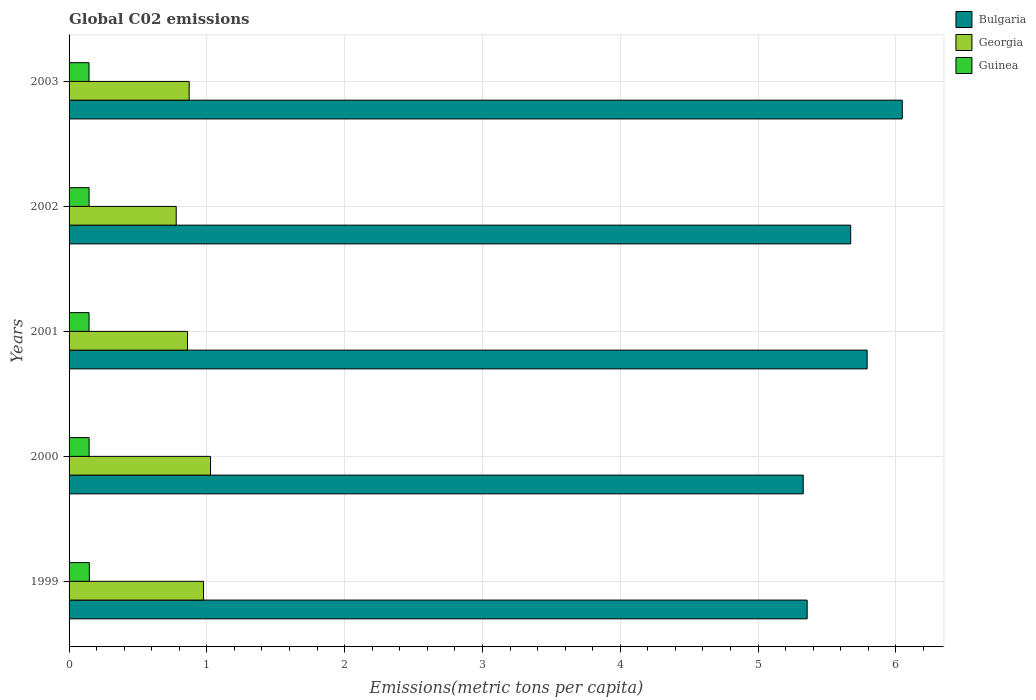Are the number of bars per tick equal to the number of legend labels?
Offer a terse response. Yes. Are the number of bars on each tick of the Y-axis equal?
Make the answer very short. Yes. How many bars are there on the 1st tick from the bottom?
Provide a short and direct response. 3. What is the label of the 1st group of bars from the top?
Keep it short and to the point. 2003. What is the amount of CO2 emitted in in Bulgaria in 2003?
Your response must be concise. 6.05. Across all years, what is the maximum amount of CO2 emitted in in Georgia?
Offer a very short reply. 1.03. Across all years, what is the minimum amount of CO2 emitted in in Guinea?
Give a very brief answer. 0.14. In which year was the amount of CO2 emitted in in Georgia maximum?
Give a very brief answer. 2000. In which year was the amount of CO2 emitted in in Bulgaria minimum?
Your response must be concise. 2000. What is the total amount of CO2 emitted in in Guinea in the graph?
Make the answer very short. 0.73. What is the difference between the amount of CO2 emitted in in Guinea in 1999 and that in 2003?
Your answer should be compact. 0. What is the difference between the amount of CO2 emitted in in Bulgaria in 1999 and the amount of CO2 emitted in in Georgia in 2002?
Keep it short and to the point. 4.58. What is the average amount of CO2 emitted in in Bulgaria per year?
Provide a short and direct response. 5.64. In the year 2001, what is the difference between the amount of CO2 emitted in in Guinea and amount of CO2 emitted in in Georgia?
Ensure brevity in your answer.  -0.71. What is the ratio of the amount of CO2 emitted in in Guinea in 2001 to that in 2002?
Your answer should be very brief. 1. What is the difference between the highest and the second highest amount of CO2 emitted in in Bulgaria?
Provide a succinct answer. 0.25. What is the difference between the highest and the lowest amount of CO2 emitted in in Georgia?
Your response must be concise. 0.25. In how many years, is the amount of CO2 emitted in in Bulgaria greater than the average amount of CO2 emitted in in Bulgaria taken over all years?
Your response must be concise. 3. Is the sum of the amount of CO2 emitted in in Guinea in 1999 and 2001 greater than the maximum amount of CO2 emitted in in Georgia across all years?
Your answer should be very brief. No. What does the 2nd bar from the top in 2001 represents?
Your response must be concise. Georgia. What does the 1st bar from the bottom in 2003 represents?
Your response must be concise. Bulgaria. How many bars are there?
Your answer should be very brief. 15. How many years are there in the graph?
Offer a terse response. 5. Are the values on the major ticks of X-axis written in scientific E-notation?
Provide a short and direct response. No. Does the graph contain grids?
Provide a succinct answer. Yes. Where does the legend appear in the graph?
Give a very brief answer. Top right. How are the legend labels stacked?
Give a very brief answer. Vertical. What is the title of the graph?
Your answer should be very brief. Global C02 emissions. What is the label or title of the X-axis?
Your response must be concise. Emissions(metric tons per capita). What is the label or title of the Y-axis?
Provide a succinct answer. Years. What is the Emissions(metric tons per capita) of Bulgaria in 1999?
Your response must be concise. 5.36. What is the Emissions(metric tons per capita) in Georgia in 1999?
Provide a succinct answer. 0.98. What is the Emissions(metric tons per capita) in Guinea in 1999?
Offer a very short reply. 0.15. What is the Emissions(metric tons per capita) of Bulgaria in 2000?
Provide a succinct answer. 5.33. What is the Emissions(metric tons per capita) in Georgia in 2000?
Provide a succinct answer. 1.03. What is the Emissions(metric tons per capita) in Guinea in 2000?
Offer a very short reply. 0.15. What is the Emissions(metric tons per capita) in Bulgaria in 2001?
Your answer should be very brief. 5.79. What is the Emissions(metric tons per capita) of Georgia in 2001?
Offer a terse response. 0.86. What is the Emissions(metric tons per capita) of Guinea in 2001?
Give a very brief answer. 0.14. What is the Emissions(metric tons per capita) of Bulgaria in 2002?
Make the answer very short. 5.67. What is the Emissions(metric tons per capita) of Georgia in 2002?
Your answer should be very brief. 0.78. What is the Emissions(metric tons per capita) of Guinea in 2002?
Keep it short and to the point. 0.15. What is the Emissions(metric tons per capita) in Bulgaria in 2003?
Offer a very short reply. 6.05. What is the Emissions(metric tons per capita) in Georgia in 2003?
Offer a terse response. 0.87. What is the Emissions(metric tons per capita) of Guinea in 2003?
Ensure brevity in your answer.  0.14. Across all years, what is the maximum Emissions(metric tons per capita) of Bulgaria?
Keep it short and to the point. 6.05. Across all years, what is the maximum Emissions(metric tons per capita) in Georgia?
Make the answer very short. 1.03. Across all years, what is the maximum Emissions(metric tons per capita) in Guinea?
Offer a terse response. 0.15. Across all years, what is the minimum Emissions(metric tons per capita) in Bulgaria?
Offer a terse response. 5.33. Across all years, what is the minimum Emissions(metric tons per capita) in Georgia?
Your answer should be compact. 0.78. Across all years, what is the minimum Emissions(metric tons per capita) in Guinea?
Provide a succinct answer. 0.14. What is the total Emissions(metric tons per capita) of Bulgaria in the graph?
Provide a short and direct response. 28.2. What is the total Emissions(metric tons per capita) of Georgia in the graph?
Offer a terse response. 4.51. What is the total Emissions(metric tons per capita) of Guinea in the graph?
Keep it short and to the point. 0.73. What is the difference between the Emissions(metric tons per capita) in Bulgaria in 1999 and that in 2000?
Provide a short and direct response. 0.03. What is the difference between the Emissions(metric tons per capita) of Georgia in 1999 and that in 2000?
Your response must be concise. -0.05. What is the difference between the Emissions(metric tons per capita) in Guinea in 1999 and that in 2000?
Offer a terse response. 0. What is the difference between the Emissions(metric tons per capita) of Bulgaria in 1999 and that in 2001?
Give a very brief answer. -0.44. What is the difference between the Emissions(metric tons per capita) in Georgia in 1999 and that in 2001?
Give a very brief answer. 0.12. What is the difference between the Emissions(metric tons per capita) in Guinea in 1999 and that in 2001?
Give a very brief answer. 0. What is the difference between the Emissions(metric tons per capita) of Bulgaria in 1999 and that in 2002?
Provide a short and direct response. -0.32. What is the difference between the Emissions(metric tons per capita) in Georgia in 1999 and that in 2002?
Offer a terse response. 0.2. What is the difference between the Emissions(metric tons per capita) in Guinea in 1999 and that in 2002?
Ensure brevity in your answer.  0. What is the difference between the Emissions(metric tons per capita) in Bulgaria in 1999 and that in 2003?
Provide a succinct answer. -0.69. What is the difference between the Emissions(metric tons per capita) of Georgia in 1999 and that in 2003?
Your response must be concise. 0.1. What is the difference between the Emissions(metric tons per capita) of Guinea in 1999 and that in 2003?
Provide a short and direct response. 0. What is the difference between the Emissions(metric tons per capita) of Bulgaria in 2000 and that in 2001?
Provide a succinct answer. -0.46. What is the difference between the Emissions(metric tons per capita) of Georgia in 2000 and that in 2001?
Keep it short and to the point. 0.17. What is the difference between the Emissions(metric tons per capita) of Guinea in 2000 and that in 2001?
Offer a terse response. 0. What is the difference between the Emissions(metric tons per capita) of Bulgaria in 2000 and that in 2002?
Provide a short and direct response. -0.34. What is the difference between the Emissions(metric tons per capita) of Georgia in 2000 and that in 2002?
Give a very brief answer. 0.25. What is the difference between the Emissions(metric tons per capita) of Bulgaria in 2000 and that in 2003?
Your answer should be compact. -0.72. What is the difference between the Emissions(metric tons per capita) in Georgia in 2000 and that in 2003?
Ensure brevity in your answer.  0.15. What is the difference between the Emissions(metric tons per capita) in Guinea in 2000 and that in 2003?
Ensure brevity in your answer.  0. What is the difference between the Emissions(metric tons per capita) in Bulgaria in 2001 and that in 2002?
Give a very brief answer. 0.12. What is the difference between the Emissions(metric tons per capita) in Georgia in 2001 and that in 2002?
Your answer should be compact. 0.08. What is the difference between the Emissions(metric tons per capita) of Guinea in 2001 and that in 2002?
Offer a terse response. -0. What is the difference between the Emissions(metric tons per capita) of Bulgaria in 2001 and that in 2003?
Ensure brevity in your answer.  -0.25. What is the difference between the Emissions(metric tons per capita) in Georgia in 2001 and that in 2003?
Your answer should be very brief. -0.01. What is the difference between the Emissions(metric tons per capita) in Bulgaria in 2002 and that in 2003?
Offer a very short reply. -0.37. What is the difference between the Emissions(metric tons per capita) in Georgia in 2002 and that in 2003?
Provide a short and direct response. -0.09. What is the difference between the Emissions(metric tons per capita) in Guinea in 2002 and that in 2003?
Your response must be concise. 0. What is the difference between the Emissions(metric tons per capita) in Bulgaria in 1999 and the Emissions(metric tons per capita) in Georgia in 2000?
Make the answer very short. 4.33. What is the difference between the Emissions(metric tons per capita) of Bulgaria in 1999 and the Emissions(metric tons per capita) of Guinea in 2000?
Offer a very short reply. 5.21. What is the difference between the Emissions(metric tons per capita) of Georgia in 1999 and the Emissions(metric tons per capita) of Guinea in 2000?
Your answer should be compact. 0.83. What is the difference between the Emissions(metric tons per capita) in Bulgaria in 1999 and the Emissions(metric tons per capita) in Georgia in 2001?
Provide a short and direct response. 4.5. What is the difference between the Emissions(metric tons per capita) of Bulgaria in 1999 and the Emissions(metric tons per capita) of Guinea in 2001?
Provide a succinct answer. 5.21. What is the difference between the Emissions(metric tons per capita) in Georgia in 1999 and the Emissions(metric tons per capita) in Guinea in 2001?
Make the answer very short. 0.83. What is the difference between the Emissions(metric tons per capita) of Bulgaria in 1999 and the Emissions(metric tons per capita) of Georgia in 2002?
Your answer should be very brief. 4.58. What is the difference between the Emissions(metric tons per capita) in Bulgaria in 1999 and the Emissions(metric tons per capita) in Guinea in 2002?
Ensure brevity in your answer.  5.21. What is the difference between the Emissions(metric tons per capita) in Georgia in 1999 and the Emissions(metric tons per capita) in Guinea in 2002?
Offer a terse response. 0.83. What is the difference between the Emissions(metric tons per capita) of Bulgaria in 1999 and the Emissions(metric tons per capita) of Georgia in 2003?
Give a very brief answer. 4.49. What is the difference between the Emissions(metric tons per capita) of Bulgaria in 1999 and the Emissions(metric tons per capita) of Guinea in 2003?
Make the answer very short. 5.21. What is the difference between the Emissions(metric tons per capita) in Georgia in 1999 and the Emissions(metric tons per capita) in Guinea in 2003?
Your answer should be very brief. 0.83. What is the difference between the Emissions(metric tons per capita) of Bulgaria in 2000 and the Emissions(metric tons per capita) of Georgia in 2001?
Offer a terse response. 4.47. What is the difference between the Emissions(metric tons per capita) in Bulgaria in 2000 and the Emissions(metric tons per capita) in Guinea in 2001?
Give a very brief answer. 5.18. What is the difference between the Emissions(metric tons per capita) of Georgia in 2000 and the Emissions(metric tons per capita) of Guinea in 2001?
Offer a very short reply. 0.88. What is the difference between the Emissions(metric tons per capita) in Bulgaria in 2000 and the Emissions(metric tons per capita) in Georgia in 2002?
Offer a terse response. 4.55. What is the difference between the Emissions(metric tons per capita) of Bulgaria in 2000 and the Emissions(metric tons per capita) of Guinea in 2002?
Offer a terse response. 5.18. What is the difference between the Emissions(metric tons per capita) of Georgia in 2000 and the Emissions(metric tons per capita) of Guinea in 2002?
Offer a very short reply. 0.88. What is the difference between the Emissions(metric tons per capita) of Bulgaria in 2000 and the Emissions(metric tons per capita) of Georgia in 2003?
Your response must be concise. 4.46. What is the difference between the Emissions(metric tons per capita) of Bulgaria in 2000 and the Emissions(metric tons per capita) of Guinea in 2003?
Ensure brevity in your answer.  5.18. What is the difference between the Emissions(metric tons per capita) in Georgia in 2000 and the Emissions(metric tons per capita) in Guinea in 2003?
Offer a terse response. 0.88. What is the difference between the Emissions(metric tons per capita) in Bulgaria in 2001 and the Emissions(metric tons per capita) in Georgia in 2002?
Your answer should be very brief. 5.01. What is the difference between the Emissions(metric tons per capita) of Bulgaria in 2001 and the Emissions(metric tons per capita) of Guinea in 2002?
Offer a very short reply. 5.65. What is the difference between the Emissions(metric tons per capita) in Georgia in 2001 and the Emissions(metric tons per capita) in Guinea in 2002?
Ensure brevity in your answer.  0.71. What is the difference between the Emissions(metric tons per capita) in Bulgaria in 2001 and the Emissions(metric tons per capita) in Georgia in 2003?
Give a very brief answer. 4.92. What is the difference between the Emissions(metric tons per capita) of Bulgaria in 2001 and the Emissions(metric tons per capita) of Guinea in 2003?
Provide a short and direct response. 5.65. What is the difference between the Emissions(metric tons per capita) of Georgia in 2001 and the Emissions(metric tons per capita) of Guinea in 2003?
Give a very brief answer. 0.71. What is the difference between the Emissions(metric tons per capita) in Bulgaria in 2002 and the Emissions(metric tons per capita) in Georgia in 2003?
Keep it short and to the point. 4.8. What is the difference between the Emissions(metric tons per capita) in Bulgaria in 2002 and the Emissions(metric tons per capita) in Guinea in 2003?
Your response must be concise. 5.53. What is the difference between the Emissions(metric tons per capita) of Georgia in 2002 and the Emissions(metric tons per capita) of Guinea in 2003?
Your answer should be very brief. 0.63. What is the average Emissions(metric tons per capita) of Bulgaria per year?
Offer a terse response. 5.64. What is the average Emissions(metric tons per capita) of Georgia per year?
Ensure brevity in your answer.  0.9. What is the average Emissions(metric tons per capita) of Guinea per year?
Ensure brevity in your answer.  0.15. In the year 1999, what is the difference between the Emissions(metric tons per capita) in Bulgaria and Emissions(metric tons per capita) in Georgia?
Provide a succinct answer. 4.38. In the year 1999, what is the difference between the Emissions(metric tons per capita) of Bulgaria and Emissions(metric tons per capita) of Guinea?
Provide a succinct answer. 5.21. In the year 1999, what is the difference between the Emissions(metric tons per capita) in Georgia and Emissions(metric tons per capita) in Guinea?
Keep it short and to the point. 0.83. In the year 2000, what is the difference between the Emissions(metric tons per capita) in Bulgaria and Emissions(metric tons per capita) in Georgia?
Ensure brevity in your answer.  4.3. In the year 2000, what is the difference between the Emissions(metric tons per capita) in Bulgaria and Emissions(metric tons per capita) in Guinea?
Ensure brevity in your answer.  5.18. In the year 2000, what is the difference between the Emissions(metric tons per capita) in Georgia and Emissions(metric tons per capita) in Guinea?
Your answer should be very brief. 0.88. In the year 2001, what is the difference between the Emissions(metric tons per capita) in Bulgaria and Emissions(metric tons per capita) in Georgia?
Offer a terse response. 4.93. In the year 2001, what is the difference between the Emissions(metric tons per capita) of Bulgaria and Emissions(metric tons per capita) of Guinea?
Provide a short and direct response. 5.65. In the year 2001, what is the difference between the Emissions(metric tons per capita) of Georgia and Emissions(metric tons per capita) of Guinea?
Make the answer very short. 0.71. In the year 2002, what is the difference between the Emissions(metric tons per capita) of Bulgaria and Emissions(metric tons per capita) of Georgia?
Provide a short and direct response. 4.89. In the year 2002, what is the difference between the Emissions(metric tons per capita) of Bulgaria and Emissions(metric tons per capita) of Guinea?
Give a very brief answer. 5.53. In the year 2002, what is the difference between the Emissions(metric tons per capita) of Georgia and Emissions(metric tons per capita) of Guinea?
Give a very brief answer. 0.63. In the year 2003, what is the difference between the Emissions(metric tons per capita) of Bulgaria and Emissions(metric tons per capita) of Georgia?
Your answer should be very brief. 5.18. In the year 2003, what is the difference between the Emissions(metric tons per capita) of Bulgaria and Emissions(metric tons per capita) of Guinea?
Offer a terse response. 5.9. In the year 2003, what is the difference between the Emissions(metric tons per capita) in Georgia and Emissions(metric tons per capita) in Guinea?
Your answer should be compact. 0.73. What is the ratio of the Emissions(metric tons per capita) in Bulgaria in 1999 to that in 2000?
Provide a succinct answer. 1.01. What is the ratio of the Emissions(metric tons per capita) in Georgia in 1999 to that in 2000?
Ensure brevity in your answer.  0.95. What is the ratio of the Emissions(metric tons per capita) in Guinea in 1999 to that in 2000?
Offer a very short reply. 1.01. What is the ratio of the Emissions(metric tons per capita) in Bulgaria in 1999 to that in 2001?
Give a very brief answer. 0.92. What is the ratio of the Emissions(metric tons per capita) in Georgia in 1999 to that in 2001?
Your answer should be compact. 1.14. What is the ratio of the Emissions(metric tons per capita) of Guinea in 1999 to that in 2001?
Offer a very short reply. 1.02. What is the ratio of the Emissions(metric tons per capita) in Bulgaria in 1999 to that in 2002?
Provide a short and direct response. 0.94. What is the ratio of the Emissions(metric tons per capita) in Georgia in 1999 to that in 2002?
Give a very brief answer. 1.25. What is the ratio of the Emissions(metric tons per capita) of Guinea in 1999 to that in 2002?
Your answer should be very brief. 1.01. What is the ratio of the Emissions(metric tons per capita) of Bulgaria in 1999 to that in 2003?
Your answer should be compact. 0.89. What is the ratio of the Emissions(metric tons per capita) of Georgia in 1999 to that in 2003?
Offer a very short reply. 1.12. What is the ratio of the Emissions(metric tons per capita) in Guinea in 1999 to that in 2003?
Make the answer very short. 1.02. What is the ratio of the Emissions(metric tons per capita) in Bulgaria in 2000 to that in 2001?
Offer a very short reply. 0.92. What is the ratio of the Emissions(metric tons per capita) of Georgia in 2000 to that in 2001?
Your response must be concise. 1.19. What is the ratio of the Emissions(metric tons per capita) in Guinea in 2000 to that in 2001?
Keep it short and to the point. 1. What is the ratio of the Emissions(metric tons per capita) in Bulgaria in 2000 to that in 2002?
Offer a very short reply. 0.94. What is the ratio of the Emissions(metric tons per capita) of Georgia in 2000 to that in 2002?
Provide a short and direct response. 1.32. What is the ratio of the Emissions(metric tons per capita) in Guinea in 2000 to that in 2002?
Give a very brief answer. 1. What is the ratio of the Emissions(metric tons per capita) of Bulgaria in 2000 to that in 2003?
Give a very brief answer. 0.88. What is the ratio of the Emissions(metric tons per capita) of Georgia in 2000 to that in 2003?
Your answer should be very brief. 1.18. What is the ratio of the Emissions(metric tons per capita) of Georgia in 2001 to that in 2002?
Offer a very short reply. 1.11. What is the ratio of the Emissions(metric tons per capita) in Bulgaria in 2001 to that in 2003?
Give a very brief answer. 0.96. What is the ratio of the Emissions(metric tons per capita) in Georgia in 2001 to that in 2003?
Provide a short and direct response. 0.99. What is the ratio of the Emissions(metric tons per capita) of Bulgaria in 2002 to that in 2003?
Offer a terse response. 0.94. What is the ratio of the Emissions(metric tons per capita) in Georgia in 2002 to that in 2003?
Provide a succinct answer. 0.89. What is the difference between the highest and the second highest Emissions(metric tons per capita) of Bulgaria?
Your response must be concise. 0.25. What is the difference between the highest and the second highest Emissions(metric tons per capita) in Georgia?
Offer a very short reply. 0.05. What is the difference between the highest and the second highest Emissions(metric tons per capita) of Guinea?
Ensure brevity in your answer.  0. What is the difference between the highest and the lowest Emissions(metric tons per capita) of Bulgaria?
Offer a terse response. 0.72. What is the difference between the highest and the lowest Emissions(metric tons per capita) of Georgia?
Make the answer very short. 0.25. What is the difference between the highest and the lowest Emissions(metric tons per capita) in Guinea?
Your answer should be compact. 0. 